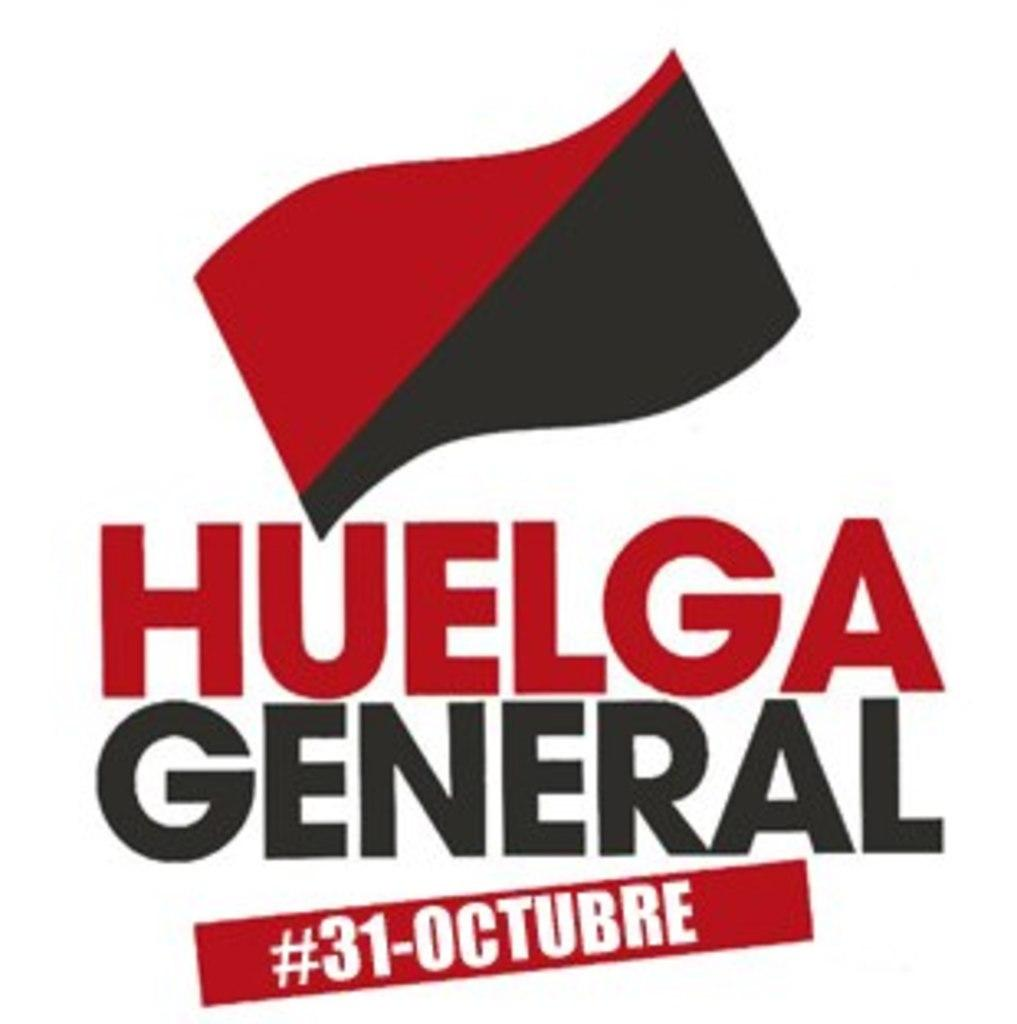<image>
Create a compact narrative representing the image presented. picture of an advertisement showing the date oct.31 